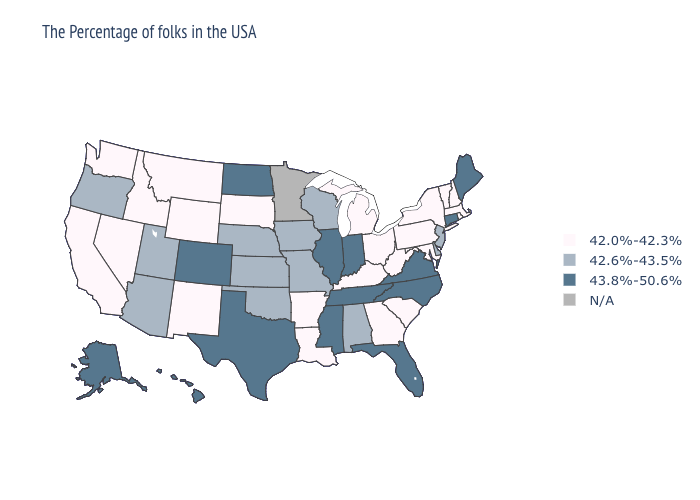Name the states that have a value in the range N/A?
Quick response, please. Minnesota. What is the value of Illinois?
Answer briefly. 43.8%-50.6%. Does Pennsylvania have the lowest value in the Northeast?
Answer briefly. Yes. What is the value of Idaho?
Write a very short answer. 42.0%-42.3%. What is the value of Maine?
Write a very short answer. 43.8%-50.6%. What is the value of Washington?
Give a very brief answer. 42.0%-42.3%. What is the value of Illinois?
Be succinct. 43.8%-50.6%. Among the states that border Delaware , does New Jersey have the lowest value?
Write a very short answer. No. Among the states that border Nevada , does Oregon have the lowest value?
Write a very short answer. No. What is the value of Colorado?
Concise answer only. 43.8%-50.6%. Which states hav the highest value in the West?
Be succinct. Colorado, Alaska, Hawaii. Name the states that have a value in the range 42.6%-43.5%?
Short answer required. New Jersey, Delaware, Alabama, Wisconsin, Missouri, Iowa, Kansas, Nebraska, Oklahoma, Utah, Arizona, Oregon. Name the states that have a value in the range 43.8%-50.6%?
Give a very brief answer. Maine, Connecticut, Virginia, North Carolina, Florida, Indiana, Tennessee, Illinois, Mississippi, Texas, North Dakota, Colorado, Alaska, Hawaii. 